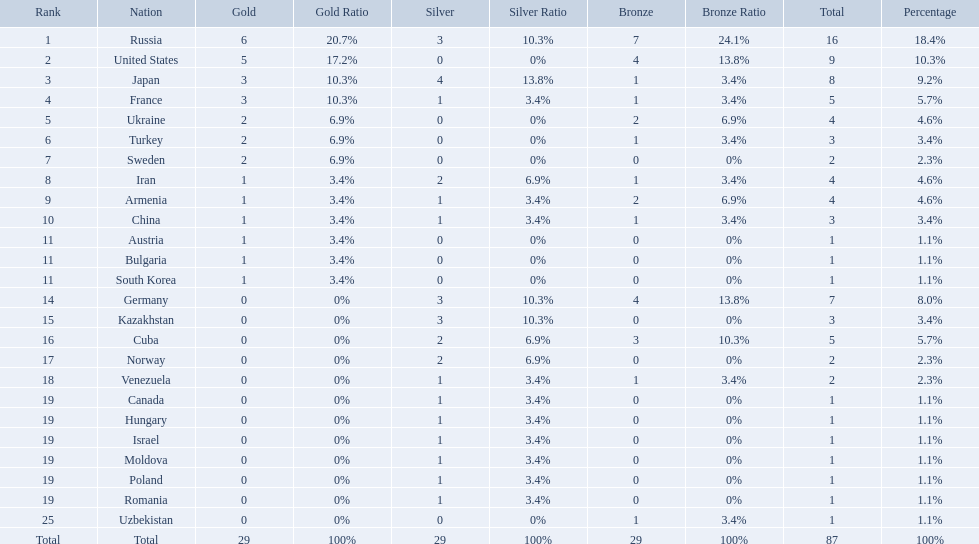Which nations are there? Russia, 6, United States, 5, Japan, 3, France, 3, Ukraine, 2, Turkey, 2, Sweden, 2, Iran, 1, Armenia, 1, China, 1, Austria, 1, Bulgaria, 1, South Korea, 1, Germany, 0, Kazakhstan, 0, Cuba, 0, Norway, 0, Venezuela, 0, Canada, 0, Hungary, 0, Israel, 0, Moldova, 0, Poland, 0, Romania, 0, Uzbekistan, 0. Which nations won gold? Russia, 6, United States, 5, Japan, 3, France, 3, Ukraine, 2, Turkey, 2, Sweden, 2, Iran, 1, Armenia, 1, China, 1, Austria, 1, Bulgaria, 1, South Korea, 1. How many golds did united states win? United States, 5. Which country has more than 5 gold medals? Russia, 6. What country is it? Russia. Which countries competed in the 1995 world wrestling championships? Russia, United States, Japan, France, Ukraine, Turkey, Sweden, Iran, Armenia, China, Austria, Bulgaria, South Korea, Germany, Kazakhstan, Cuba, Norway, Venezuela, Canada, Hungary, Israel, Moldova, Poland, Romania, Uzbekistan. What country won only one medal? Austria, Bulgaria, South Korea, Canada, Hungary, Israel, Moldova, Poland, Romania, Uzbekistan. Which of these won a bronze medal? Uzbekistan. Which nations participated in the championships? Russia, United States, Japan, France, Ukraine, Turkey, Sweden, Iran, Armenia, China, Austria, Bulgaria, South Korea, Germany, Kazakhstan, Cuba, Norway, Venezuela, Canada, Hungary, Israel, Moldova, Poland, Romania, Uzbekistan. How many bronze medals did they receive? 7, 4, 1, 1, 2, 1, 0, 1, 2, 1, 0, 0, 0, 4, 0, 3, 0, 1, 0, 0, 0, 0, 0, 0, 1, 29. How many in total? 16, 9, 8, 5, 4, 3, 2, 4, 4, 3, 1, 1, 1, 7, 3, 5, 2, 2, 1, 1, 1, 1, 1, 1, 1. And which team won only one medal -- the bronze? Uzbekistan. How many countries competed? Israel. Parse the full table. {'header': ['Rank', 'Nation', 'Gold', 'Gold Ratio', 'Silver', 'Silver Ratio', 'Bronze', 'Bronze Ratio', 'Total', 'Percentage'], 'rows': [['1', 'Russia', '6', '20.7%', '3', '10.3%', '7', '24.1%', '16', '18.4%'], ['2', 'United States', '5', '17.2%', '0', '0%', '4', '13.8%', '9', '10.3%'], ['3', 'Japan', '3', '10.3%', '4', '13.8%', '1', '3.4%', '8', '9.2%'], ['4', 'France', '3', '10.3%', '1', '3.4%', '1', '3.4%', '5', '5.7%'], ['5', 'Ukraine', '2', '6.9%', '0', '0%', '2', '6.9%', '4', '4.6%'], ['6', 'Turkey', '2', '6.9%', '0', '0%', '1', '3.4%', '3', '3.4%'], ['7', 'Sweden', '2', '6.9%', '0', '0%', '0', '0%', '2', '2.3%'], ['8', 'Iran', '1', '3.4%', '2', '6.9%', '1', '3.4%', '4', '4.6%'], ['9', 'Armenia', '1', '3.4%', '1', '3.4%', '2', '6.9%', '4', '4.6%'], ['10', 'China', '1', '3.4%', '1', '3.4%', '1', '3.4%', '3', '3.4%'], ['11', 'Austria', '1', '3.4%', '0', '0%', '0', '0%', '1', '1.1%'], ['11', 'Bulgaria', '1', '3.4%', '0', '0%', '0', '0%', '1', '1.1%'], ['11', 'South Korea', '1', '3.4%', '0', '0%', '0', '0%', '1', '1.1%'], ['14', 'Germany', '0', '0%', '3', '10.3%', '4', '13.8%', '7', '8.0%'], ['15', 'Kazakhstan', '0', '0%', '3', '10.3%', '0', '0%', '3', '3.4%'], ['16', 'Cuba', '0', '0%', '2', '6.9%', '3', '10.3%', '5', '5.7%'], ['17', 'Norway', '0', '0%', '2', '6.9%', '0', '0%', '2', '2.3%'], ['18', 'Venezuela', '0', '0%', '1', '3.4%', '1', '3.4%', '2', '2.3%'], ['19', 'Canada', '0', '0%', '1', '3.4%', '0', '0%', '1', '1.1%'], ['19', 'Hungary', '0', '0%', '1', '3.4%', '0', '0%', '1', '1.1%'], ['19', 'Israel', '0', '0%', '1', '3.4%', '0', '0%', '1', '1.1%'], ['19', 'Moldova', '0', '0%', '1', '3.4%', '0', '0%', '1', '1.1%'], ['19', 'Poland', '0', '0%', '1', '3.4%', '0', '0%', '1', '1.1%'], ['19', 'Romania', '0', '0%', '1', '3.4%', '0', '0%', '1', '1.1%'], ['25', 'Uzbekistan', '0', '0%', '0', '0%', '1', '3.4%', '1', '1.1%'], ['Total', 'Total', '29', '100%', '29', '100%', '29', '100%', '87', '100%']]} How many total medals did russia win? 16. What country won only 1 medal? Uzbekistan. What nations have one gold medal? Iran, Armenia, China, Austria, Bulgaria, South Korea. Of these, which nations have zero silver medals? Austria, Bulgaria, South Korea. Of these, which nations also have zero bronze medals? Austria. Which nations have gold medals? Russia, United States, Japan, France, Ukraine, Turkey, Sweden, Iran, Armenia, China, Austria, Bulgaria, South Korea. Of those nations, which have only one gold medal? Iran, Armenia, China, Austria, Bulgaria, South Korea. Of those nations, which has no bronze or silver medals? Austria. 